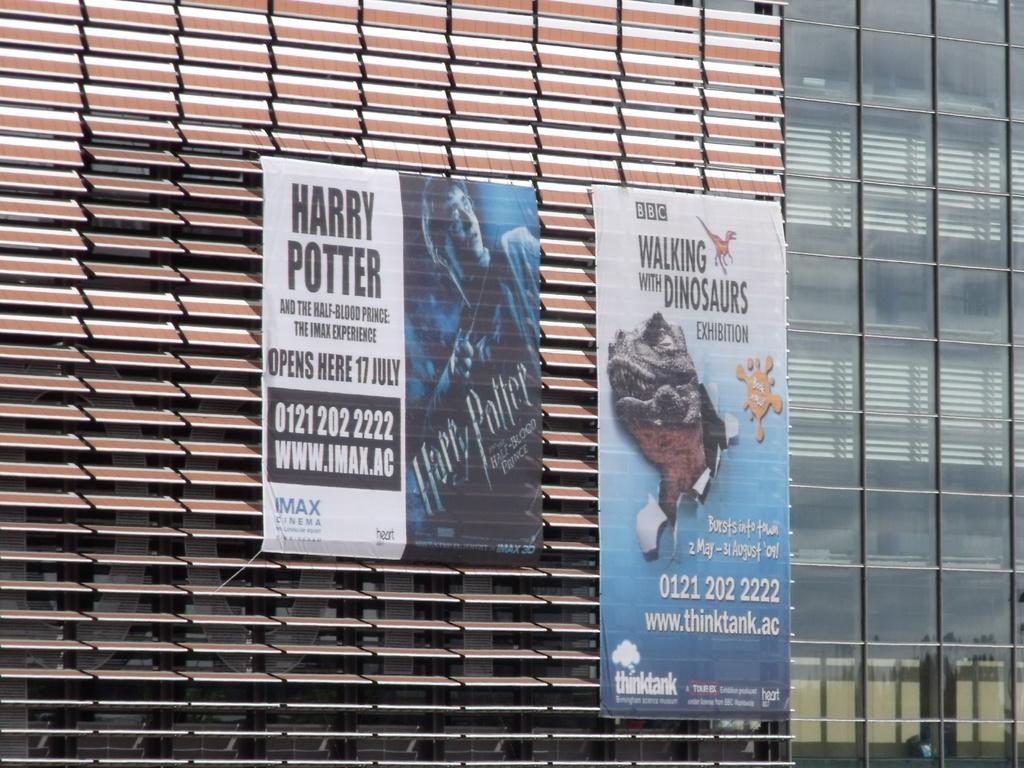What type of exhibition is promoted by the bbc in the poster on the right?
Offer a terse response. Walking with dinosaurs. 